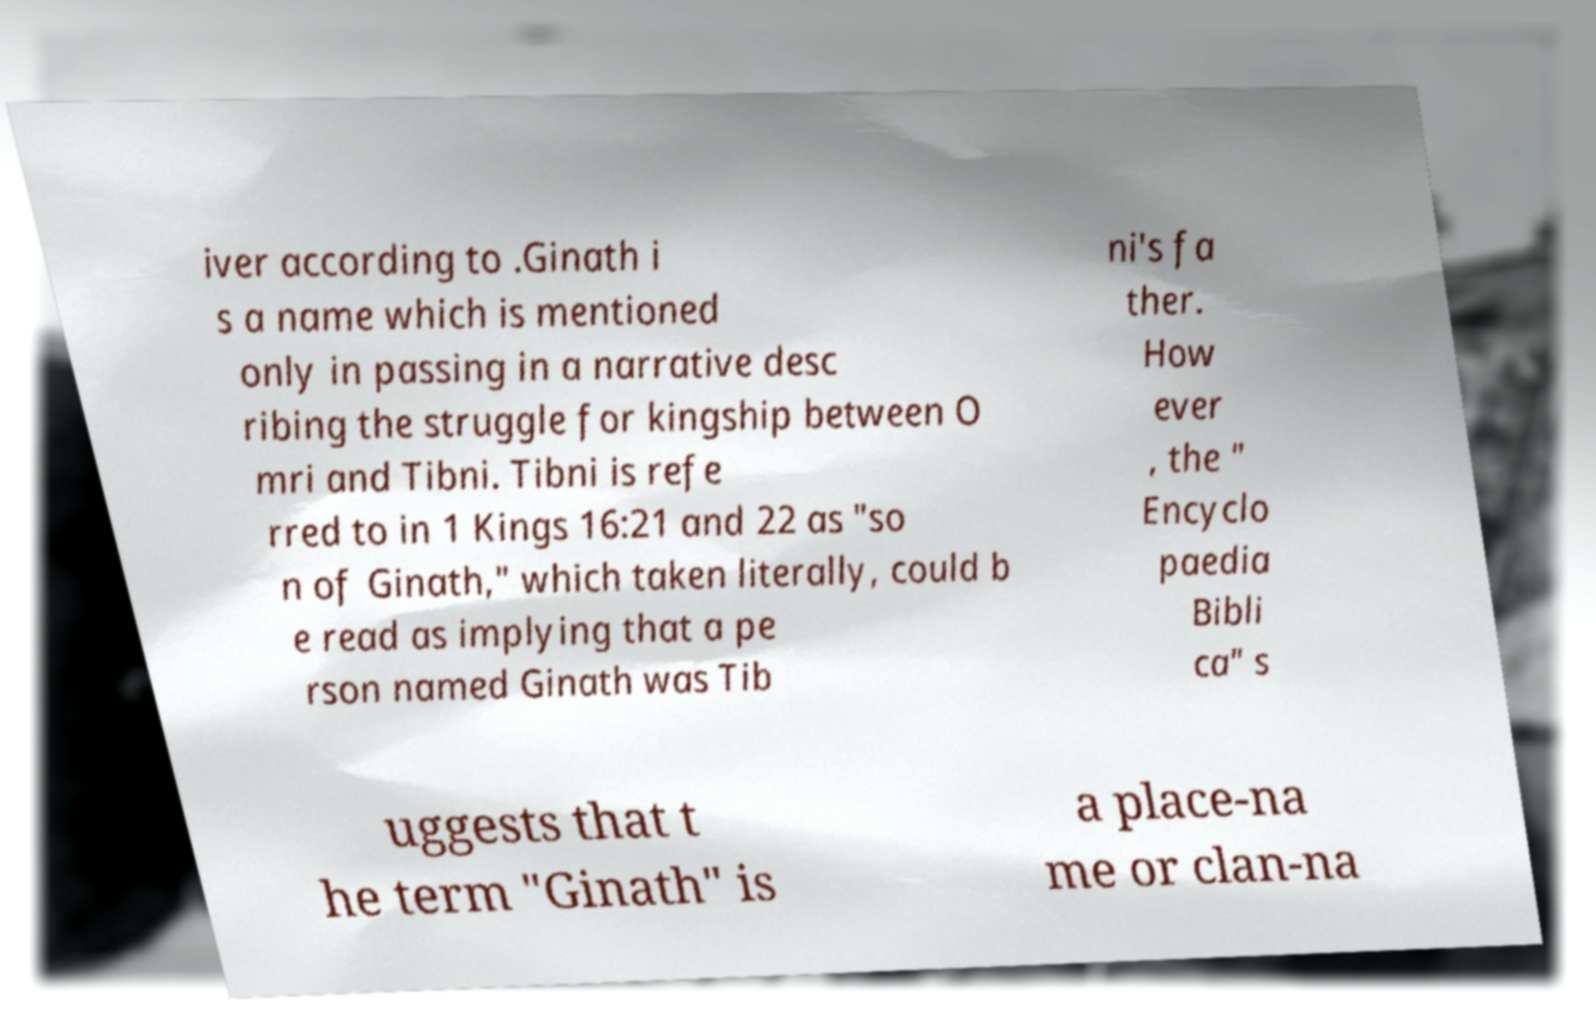There's text embedded in this image that I need extracted. Can you transcribe it verbatim? iver according to .Ginath i s a name which is mentioned only in passing in a narrative desc ribing the struggle for kingship between O mri and Tibni. Tibni is refe rred to in 1 Kings 16:21 and 22 as "so n of Ginath," which taken literally, could b e read as implying that a pe rson named Ginath was Tib ni's fa ther. How ever , the " Encyclo paedia Bibli ca" s uggests that t he term "Ginath" is a place-na me or clan-na 